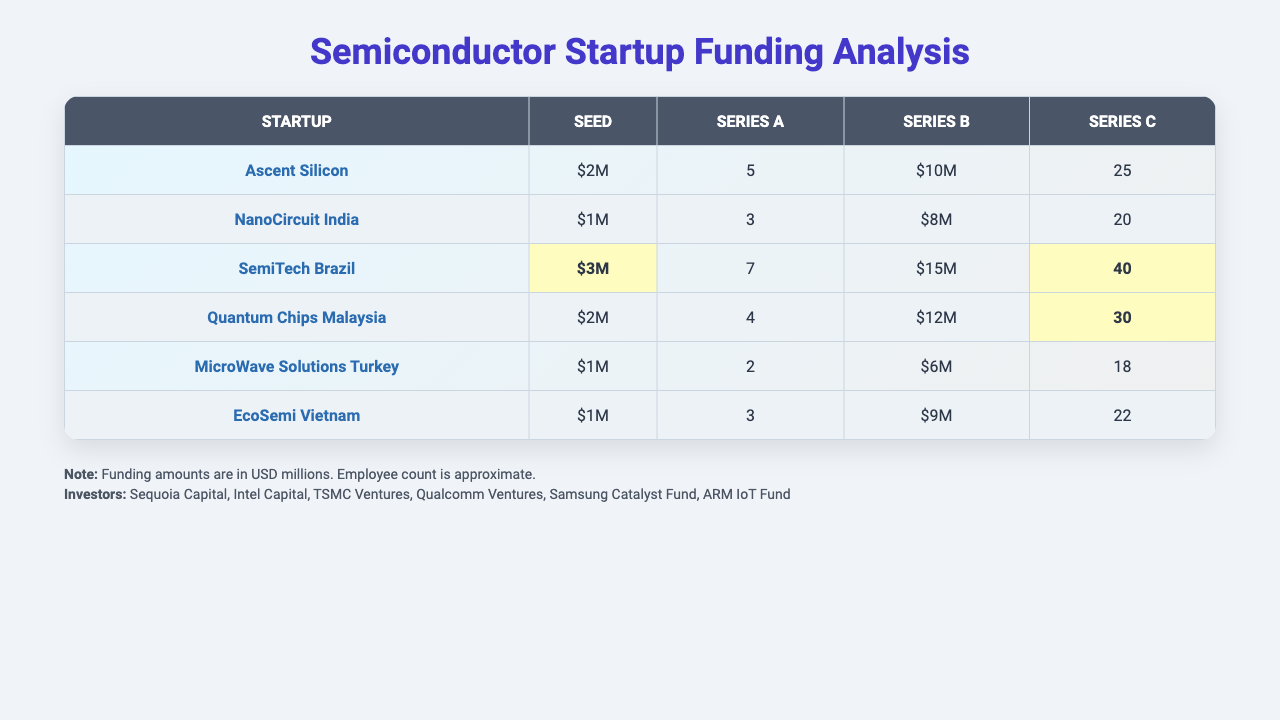What startup has the highest Seed funding? By reviewing the Seed funding column, we find that SemiTech Brazil has the highest Seed funding amount of $3M.
Answer: SemiTech Brazil Which startup has the highest employee count? Looking at the Employee Count column, SemiTech Brazil has the highest count with 40 employees.
Answer: SemiTech Brazil How many startups received Series B funding? Counting the number of startups with values in the Series B column, there are 6 startups listed with Series B funding.
Answer: 6 What is the total funding amount for Quantum Chips Malaysia across all funding rounds? Summing the values from all funding rounds for Quantum Chips Malaysia: 2+4+12+30 = 48 million.
Answer: $48M Which funding round has the highest average funding amount across all startups? Calculating the average for each funding round: Seed: (2+1+3+2+1+1)/6 = 1.67, Series A: (5+3+7+4+2+3)/6 = 4, Series B: (10+8+15+12+6+9)/6 = 10, Series C: (25+20+40+30+18+22)/6 = 24.17. Series C has the highest average funding amount.
Answer: Series C Did EcoSemi Vietnam receive more funding in Series A than Ascent Silicon in Series B? EcoSemi Vietnam received $3M in Series A while Ascent Silicon received $10M in Series B. Since 10M is greater than 3M, the statement is false.
Answer: No What is the difference in post-money valuation between the startup with the highest and the lowest valuation in Series C? Looking at Series C, the highest valuation is $30M (Quantum Chips Malaysia) and the lowest is $18M (MicroWave Solutions Turkey). The difference is 30 - 18 = 12 million.
Answer: $12M How many investors participated in the highest funding round for SemiTech Brazil? SemiTech Brazil received $15M in the Series B funding round, and according to the table, this round had 3 investors.
Answer: 3 Which startup received the lowest funding in Series A? By checking the Series A column, we see that MicroWave Solutions Turkey received only $2M, which is the lowest amount in that round.
Answer: MicroWave Solutions Turkey If you average the employee counts of all listed startups, what is the result? Summing all employee counts: (25 + 20 + 40 + 30 + 18 + 22) = 165; dividing by the number of startups (6): 165/6 = 27.5.
Answer: 27.5 